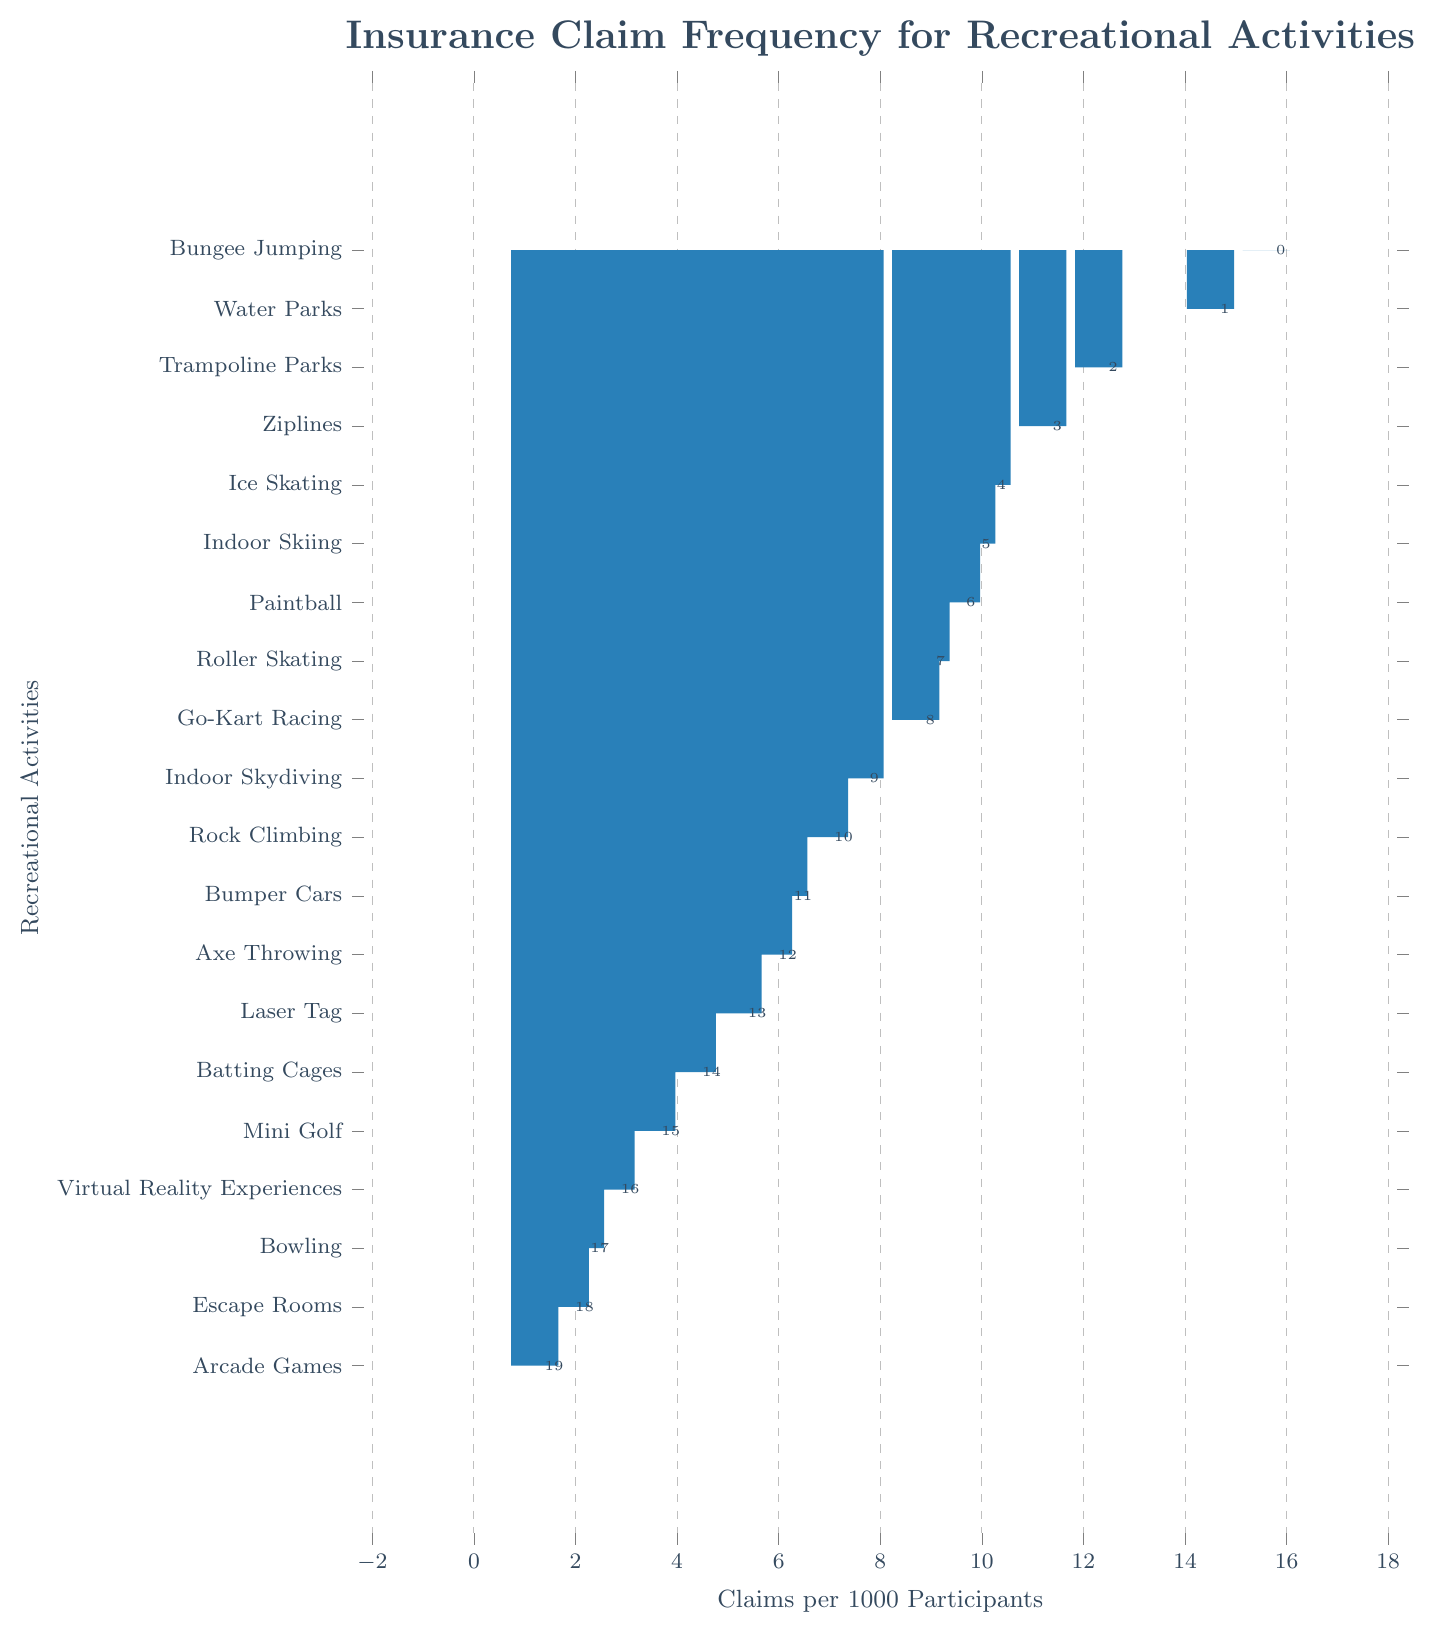Which activity has the highest insurance claim frequency? The activity with the highest insurance claim frequency will be the tallest bar in the bar chart.
Answer: Bungee Jumping What's the difference in claims per 1000 participants between Water Parks and Trampoline Parks? First, identify the values for Water Parks (14.5) and Trampoline Parks (12.3), then subtract the smaller value from the larger one: 14.5 - 12.3.
Answer: 2.2 Which two activities have the lowest claim frequencies? Look at the two shortest bars in the bar chart. The activities corresponding to these bars are the ones with the lowest claim frequencies.
Answer: Arcade Games, Escape Rooms What is the combined insurance claim frequency of Go-Kart Racing and Roller Skating? Identify the claim frequencies for Go-Kart Racing (8.7) and Roller Skating (8.9), then add them together: 8.7 + 8.9.
Answer: 17.6 Is the claim frequency of Paintball greater or less than Bumper Cars? Compare the height of the bars for Paintball (9.5) and Bumper Cars (6.1).
Answer: Greater What's the range of insurance claim frequencies across all activities? Subtract the smallest claim frequency (Arcade Games: 1.2) from the largest claim frequency (Bungee Jumping: 15.6): 15.6 - 1.2.
Answer: 14.4 Which activity has a claim frequency closest to 5 per 1000 participants? Find the activity whose bar is closest to the value 5 on the x-axis.
Answer: Laser Tag (5.2) How many activities have claim frequencies greater than 10 per 1000 participants? Count the number of bars with lengths exceeding the 10 value on the x-axis.
Answer: 5 What is the average insurance claim frequency for the activities with claim frequencies above 10 per 1000 participants? Identify the frequencies above 10 (Bungee Jumping: 15.6, Water Parks: 14.5, Trampoline Parks: 12.3, Ziplines: 11.2, Ice Skating: 10.1), sum them (15.6 + 14.5 + 12.3 + 11.2 + 10.1), and divide by the number of these activities (5): (15.6 + 14.5 + 12.3 + 11.2 + 10.1) / 5.
Answer: 12.74 Is the claim frequency for Rock Climbing higher or lower than Axe Throwing? Compare the heights of the bars for Rock Climbing (6.9) and Axe Throwing (5.8).
Answer: Higher 